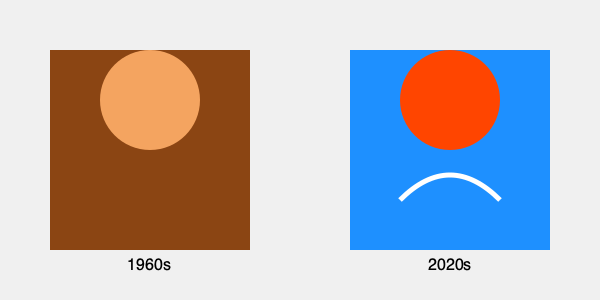Looking at the illustrations of football uniforms from the 1960s and 2020s, what key difference in design philosophy is evident, and how might this reflect changes in the sport over time? To answer this question, we need to examine the differences between the two illustrations:

1. 1960s uniform:
   - Simple, solid color scheme (brown)
   - No visible logos or decorations
   - Basic, functional design

2. 2020s uniform:
   - Brighter, more vibrant color scheme (blue and orange)
   - Visible swoosh or curved line, possibly representing a logo or modern design element
   - More complex overall design

The key difference in design philosophy is the shift from simplicity to complexity and branding. This reflects several changes in the sport over time:

1. Commercialization: The addition of logos and more eye-catching designs reflects the increased commercialization of football, with teams and players becoming valuable brands.

2. Technology: Brighter colors and more complex designs are made possible by advancements in fabric technology and manufacturing processes.

3. Media influence: As football became more televised, uniforms evolved to be more visually appealing on screen.

4. Performance: Modern designs often incorporate elements that may enhance performance, such as streamlined shapes or moisture-wicking materials.

This shift from simple, functional uniforms to more complex, branded designs mirrors the overall evolution of football from a straightforward athletic contest to a multi-billion dollar entertainment industry.
Answer: Shift from simplicity to complexity and branding, reflecting commercialization and technological advancements in football. 